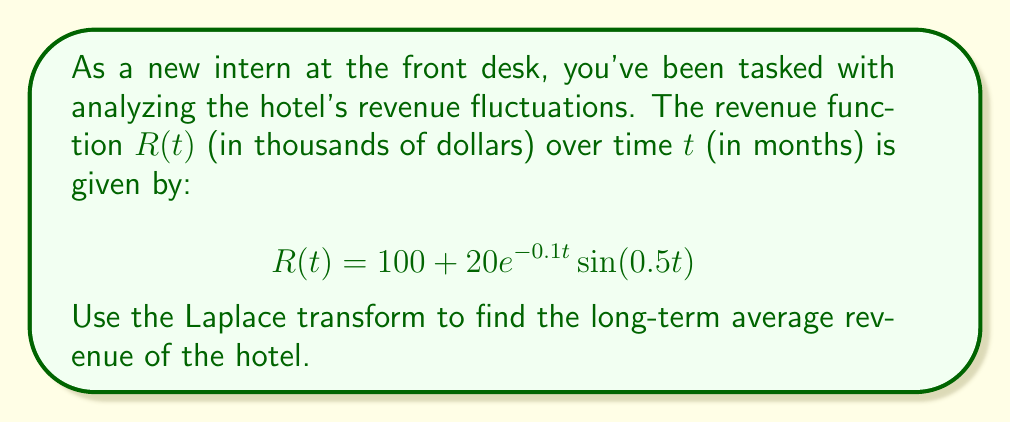Help me with this question. To solve this problem, we'll follow these steps:

1) Recall the Final Value Theorem for Laplace transforms:
   If $\lim_{t \to \infty} f(t)$ exists, then $\lim_{t \to \infty} f(t) = \lim_{s \to 0} sF(s)$, where $F(s)$ is the Laplace transform of $f(t)$.

2) First, let's find the Laplace transform of $R(t)$:
   
   $\mathcal{L}\{R(t)\} = \mathcal{L}\{100\} + \mathcal{L}\{20e^{-0.1t}\sin(0.5t)\}$

3) We know that:
   $\mathcal{L}\{100\} = \frac{100}{s}$
   
   $\mathcal{L}\{e^{at}\sin(bt)\} = \frac{b}{(s-a)^2 + b^2}$

4) Therefore:
   
   $R(s) = \frac{100}{s} + 20 \cdot \frac{0.5}{(s+0.1)^2 + 0.5^2}$

5) Now, let's apply the Final Value Theorem:
   
   $\lim_{t \to \infty} R(t) = \lim_{s \to 0} sR(s)$

6) Calculating the limit:
   
   $\lim_{s \to 0} s(\frac{100}{s} + 20 \cdot \frac{0.5}{(s+0.1)^2 + 0.5^2})$
   
   $= \lim_{s \to 0} (100 + 20s \cdot \frac{0.5}{(s+0.1)^2 + 0.5^2})$
   
   $= 100 + 0 = 100$

Therefore, the long-term average revenue of the hotel is $100,000 per month.
Answer: $100,000 per month 